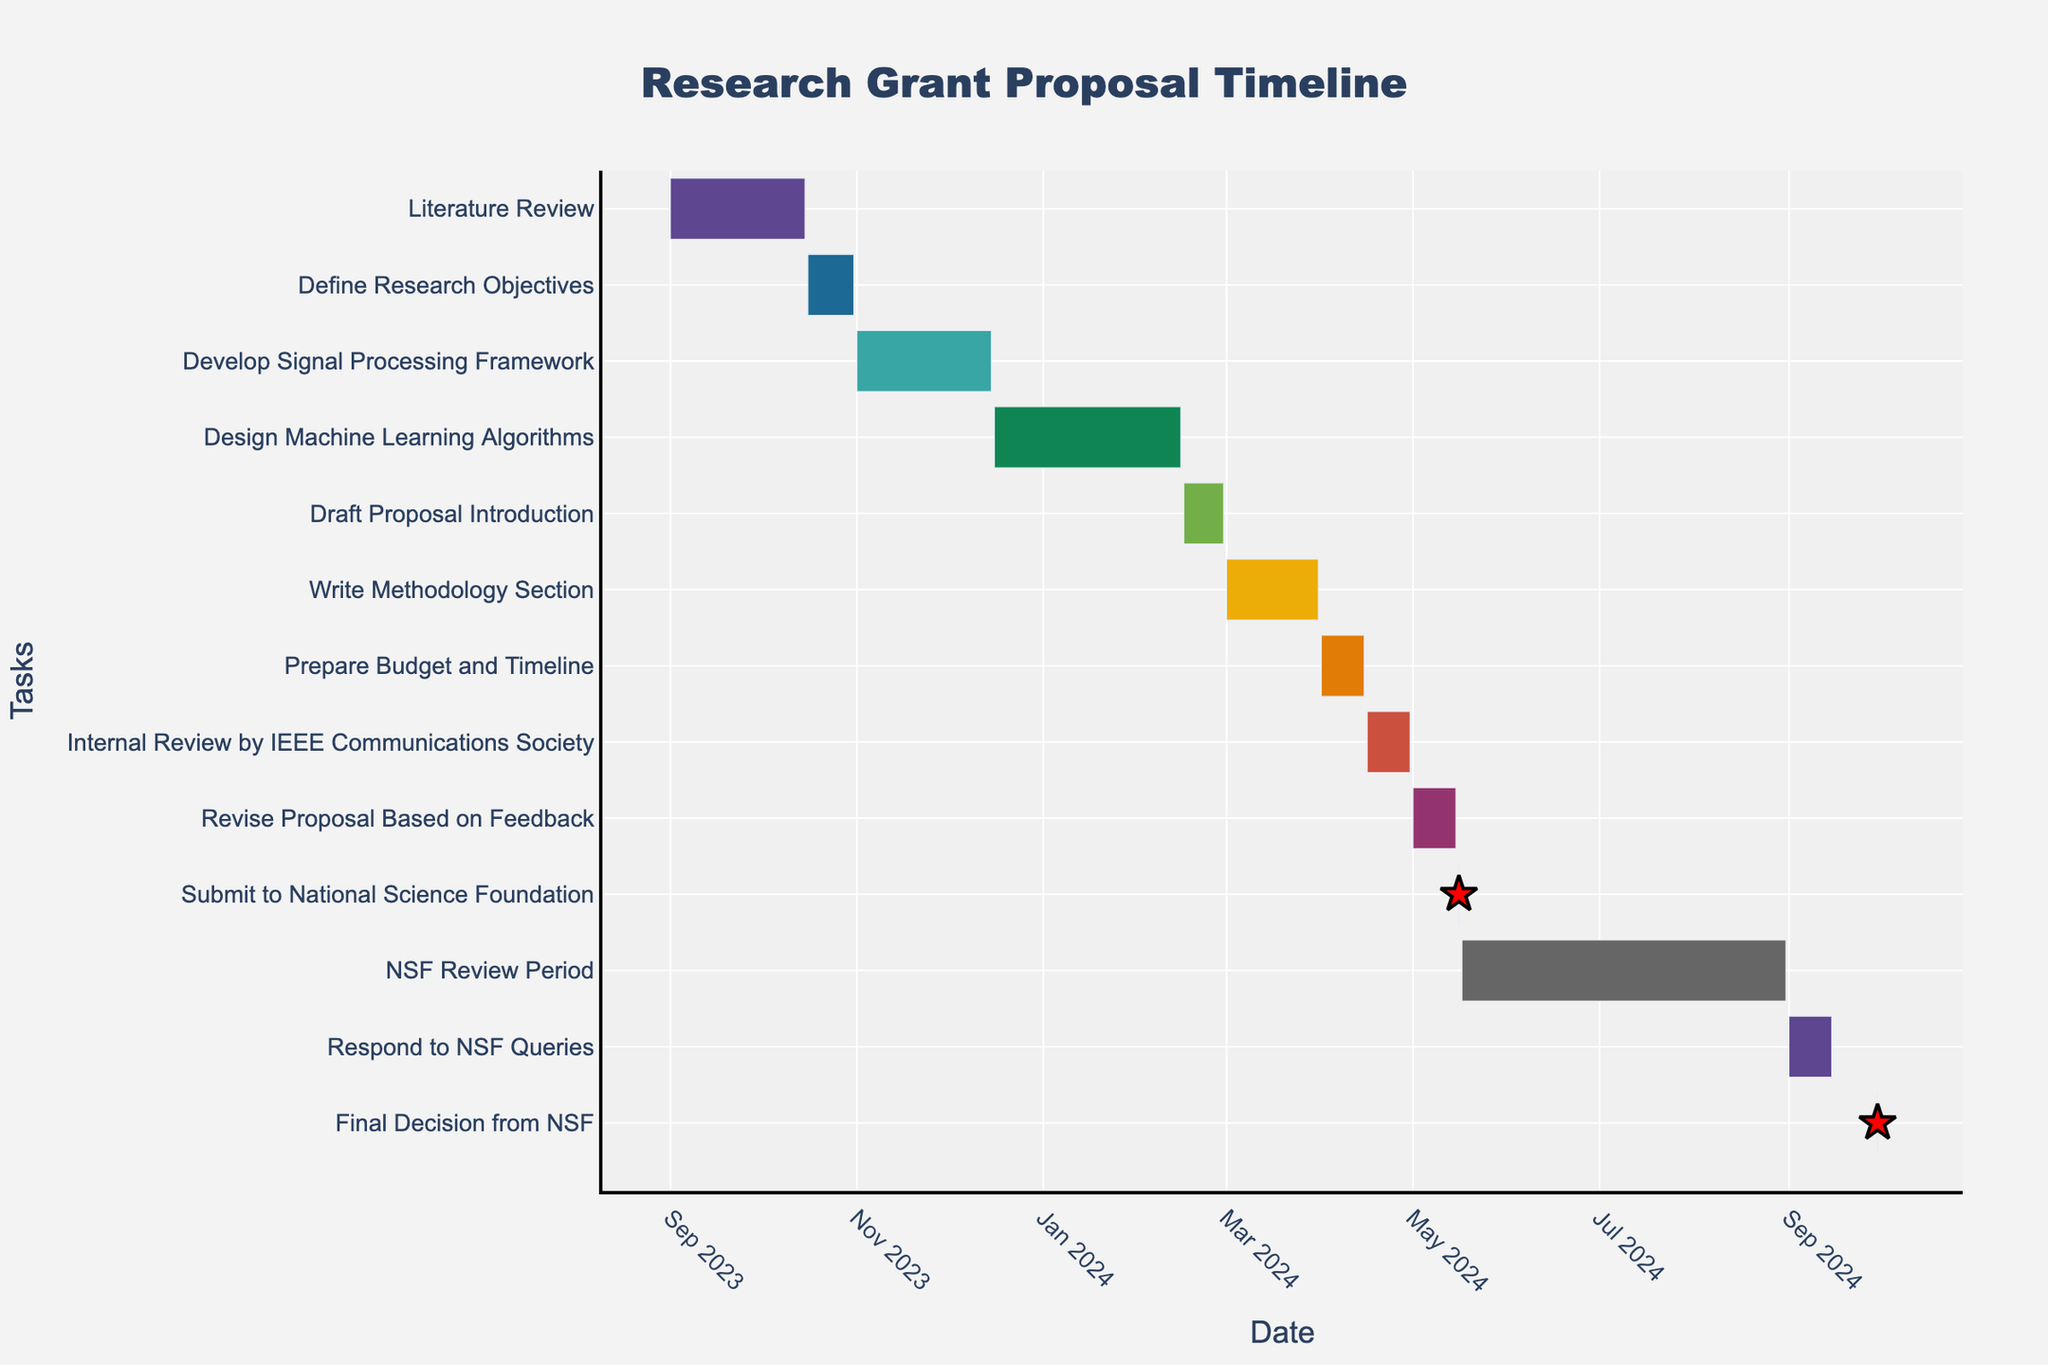How long is the Literature Review stage? The Literature Review stage starts on 2023-09-01 and ends on 2023-10-15. Measuring the duration involves calculating the difference between these two dates. This stage lasts for 45 days.
Answer: 45 days What is the title of the Gantt chart? The title of the Gantt chart is displayed at the top of the figure. It reads "Research Grant Proposal Timeline."
Answer: Research Grant Proposal Timeline Which task starts immediately after the Design Machine Learning Algorithms stage? By looking at the end date of the Design Machine Learning Algorithms task (2024-02-15) and finding the next task's start date, the Introduction Draft Proposal stage starts immediately after on 2024-02-16.
Answer: Draft Proposal Introduction How many tasks have a duration of less than or equal to 15 days? Reviewing the durations of all tasks, the following tasks have a duration of 15 days or less: Define Research Objectives (15 days), Draft Proposal Introduction (14 days), Prepare Budget and Timeline (15 days), Internal Review by IEEE Communications Society (15 days), Revise Proposal Based on Feedback (15 days), Submit to National Science Foundation (1 day), Respond to NSF Queries (15 days), and Final Decision from NSF (1 day). So, there are 8 such tasks.
Answer: 8 tasks Which task lasts the longest and how many days does it take? By comparing the durations, the NSF Review Period, which spans from 2024-05-17 to 2024-08-31, is the longest duration. It lasts for 107 days.
Answer: NSF Review Period, 107 days Do the Development Signal Processing Framework and Design Machine Learning Algorithms stages overlap? The Development Signal Processing Framework stage ends on 2023-12-15, and the Design Machine Learning Algorithms stage starts on 2023-12-16. Since the first task ends one day before the next begins, there is no overlap.
Answer: No What are the two milestones in this timeline? Milestones are represented as single-day tasks. From the data, the two milestones are "Submit to National Science Foundation" on 2024-05-16 and "Final Decision from NSF" on 2024-09-30.
Answer: Submit to National Science Foundation and Final Decision from NSF What's the cumulative duration for the tasks that occur in the first half of 2024? The tasks in the first half of 2024 include:
1. Draft Proposal Introduction (2024-02-16 to 2024-02-29) - 14 days
2. Write Methodology Section (2024-03-01 to 2024-03-31) - 31 days
3. Prepare Budget and Timeline (2024-04-01 to 2024-04-15) - 15 days
4. Internal Review by IEEE Communications Society (2024-04-16 to 2024-04-30) - 15 days
5. Revise Proposal Based on Feedback (2024-05-01 to 2024-05-15) - 15 days
6. Submit to National Science Foundation (2024-05-16) - 1 day
Summing these up, the cumulative duration is 91 days.
Answer: 91 days 